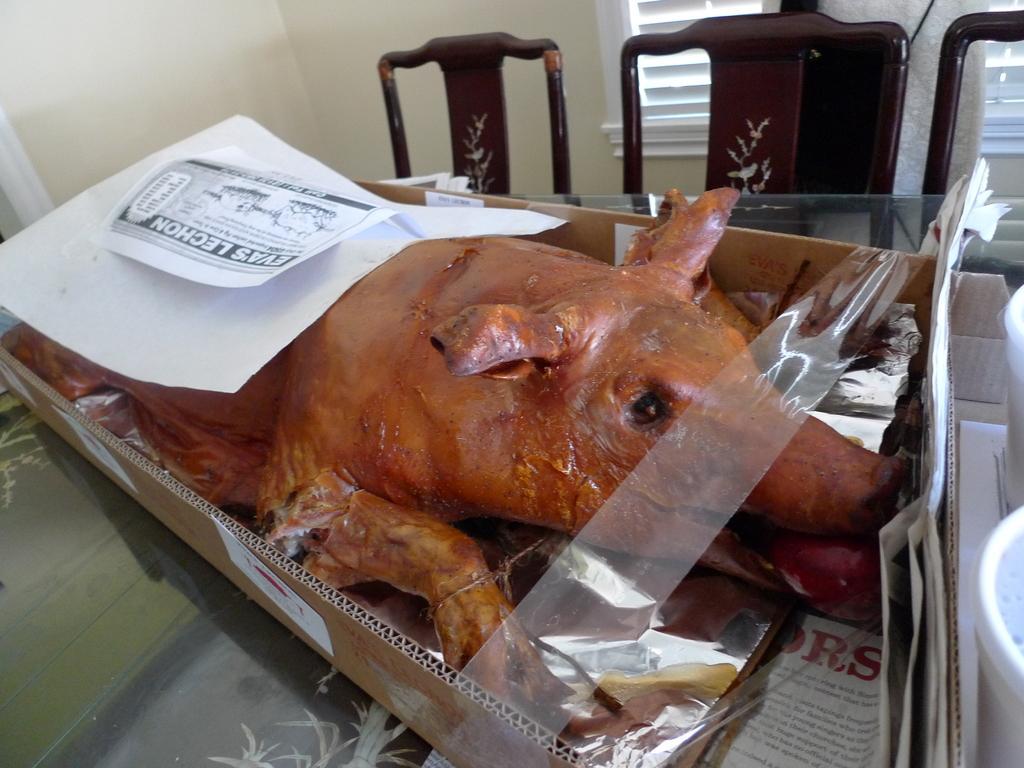Can you describe this image briefly? In the center of the image, we can see a pork in the box and there are papers, containers are on the table. In the background, there are chairs, cloth and we can see a window and a wall. 